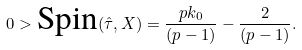<formula> <loc_0><loc_0><loc_500><loc_500>0 > \text {Spin} ( \hat { \tau } , X ) = \frac { p k _ { 0 } } { ( p - 1 ) } - \frac { 2 } { ( p - 1 ) } .</formula> 